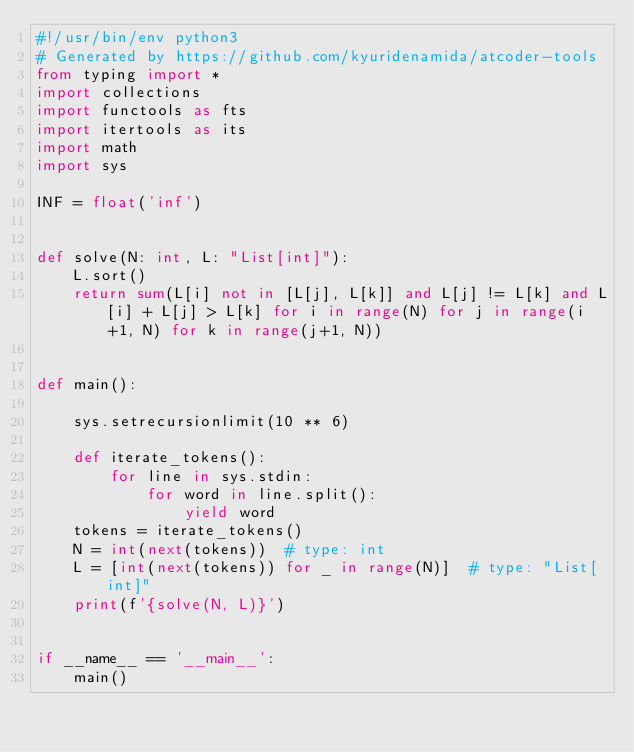Convert code to text. <code><loc_0><loc_0><loc_500><loc_500><_Python_>#!/usr/bin/env python3
# Generated by https://github.com/kyuridenamida/atcoder-tools
from typing import *
import collections
import functools as fts
import itertools as its
import math
import sys

INF = float('inf')


def solve(N: int, L: "List[int]"):
    L.sort()
    return sum(L[i] not in [L[j], L[k]] and L[j] != L[k] and L[i] + L[j] > L[k] for i in range(N) for j in range(i+1, N) for k in range(j+1, N))


def main():

    sys.setrecursionlimit(10 ** 6)

    def iterate_tokens():
        for line in sys.stdin:
            for word in line.split():
                yield word
    tokens = iterate_tokens()
    N = int(next(tokens))  # type: int
    L = [int(next(tokens)) for _ in range(N)]  # type: "List[int]"
    print(f'{solve(N, L)}')


if __name__ == '__main__':
    main()
</code> 